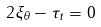Convert formula to latex. <formula><loc_0><loc_0><loc_500><loc_500>2 \xi _ { \theta } - \tau _ { t } = 0</formula> 